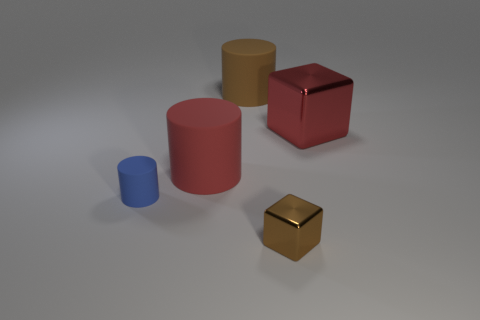How many blue objects have the same size as the red matte object? There are no blue objects that match the size of the red matte cube in the image. The red matte cube is unique in size compared to the blue objects presented. 